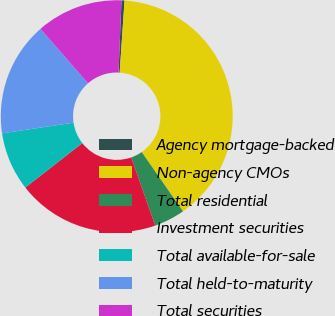Convert chart. <chart><loc_0><loc_0><loc_500><loc_500><pie_chart><fcel>Agency mortgage-backed<fcel>Non-agency CMOs<fcel>Total residential<fcel>Investment securities<fcel>Total available-for-sale<fcel>Total held-to-maturity<fcel>Total securities<nl><fcel>0.42%<fcel>39.25%<fcel>4.3%<fcel>19.83%<fcel>8.18%<fcel>15.95%<fcel>12.07%<nl></chart> 